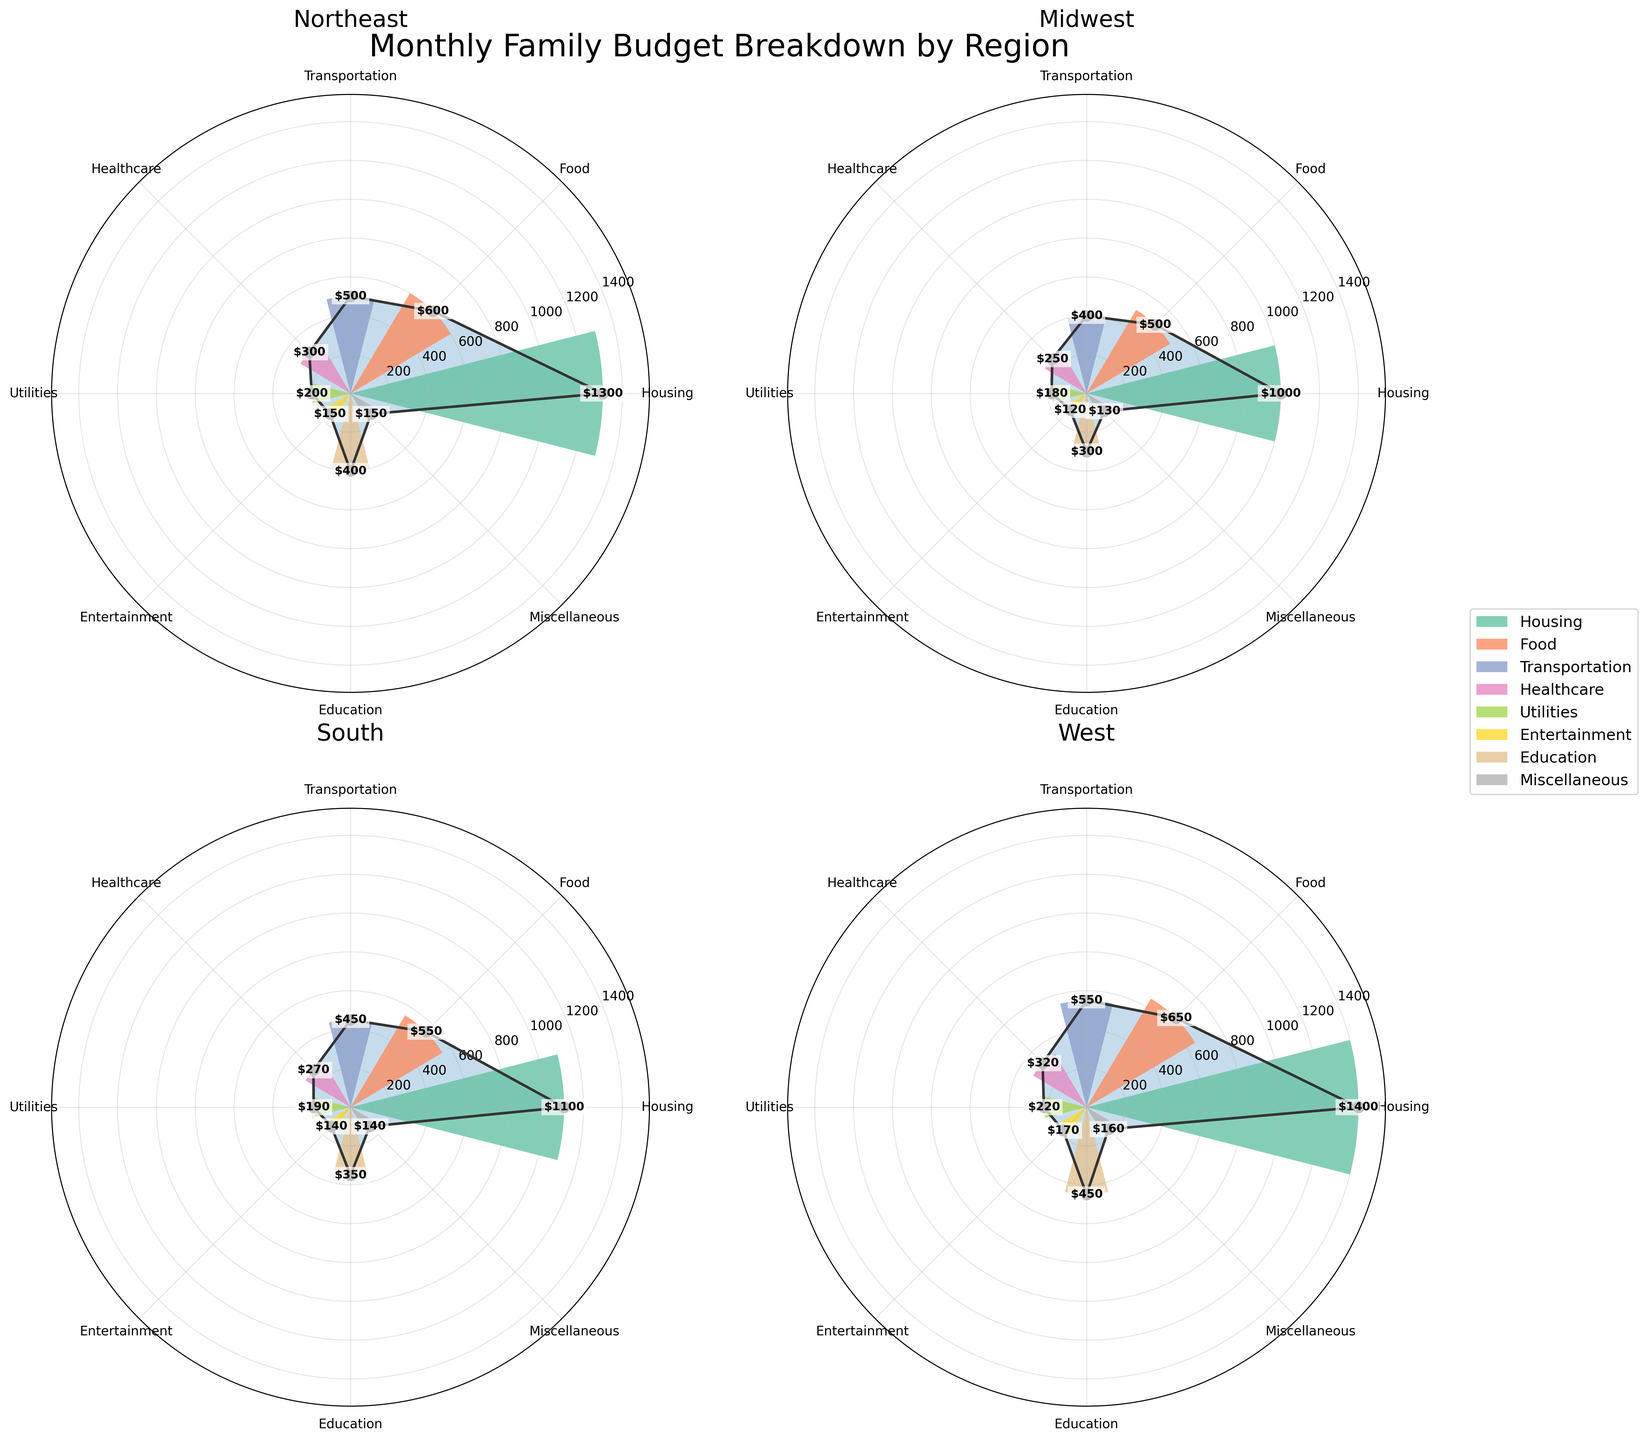What is the title of the chart? The title of a chart is usually placed at the top and it provides an overall description of the chart content. In this case, it summarizes the data being displayed.
Answer: Monthly Family Budget Breakdown by Region Which region has the highest Housing expense? The chart displays the Housing expenses for each region as bars in different colors on the rose chart. By identifying the height of these bars, we can determine which region has the highest value.
Answer: West What are the categories depicted in the legend? The legend of the chart contains colored rectangles corresponding to each category, placed alongside the category names. This helps in identifying the expense categories in the rose chart.
Answer: Housing, Food, Transportation, Healthcare, Utilities, Entertainment, Education, Miscellaneous Which region has the smallest Entertainment expense? By visually inspecting the bars representing Entertainment across all regions and finding the shortest one, we can identify the region with the smallest value.
Answer: Midwest What is the total monthly expense in the Northeast region by adding all categories? Sum the monthly expenses for each category listed under the Northeast region in the data table: $1300 (Housing) + $600 (Food) + $500 (Transportation) + $300 (Healthcare) + $200 (Utilities) + $150 (Entertainment) + $400 (Education) + $150 (Miscellaneous)
Answer: $3600 How does the Education expense in the South compare to the West? Compare the heights of the bars representing Education in the South and the West regions. The West has a higher Education expense than the South.
Answer: West has higher expense If you combine the Transportation and Utilities expenses, which region has the highest combined value? Add the values of Transportation and Utilities for each region and compare: 
Northeast: $500 + $200 = $700 
Midwest: $400 + $180 = $580 
South: $450 + $190 = $640 
West: $550 + $220 = $770. The West has the highest combined value.
Answer: West Which region has the lowest Healthcare expense, and what is its value? Identify the shortest bar representing Healthcare in the rose chart and read the value associated with it.
Answer: Midwest, $250 What is the visual appearance used to represent the data points of each expense category in the rose chart? The data points for each expense category are represented using bars with different colors, arranged radially around a central point. Each colored bar's height indicates the expense amount and is labeled with the value.
Answer: Colored radial bars and value labels Is there a region where the Food expense is higher than the Housing expense? Compare the heights of the bars representing Food and Housing for all regions. In all regions, the Housing expenses are higher than the Food expenses specifically: 
Northeast: $1300 vs $600 
Midwest: $1000 vs $500 
South: $1100 vs $550 
West: $1400 vs $650
Answer: No 